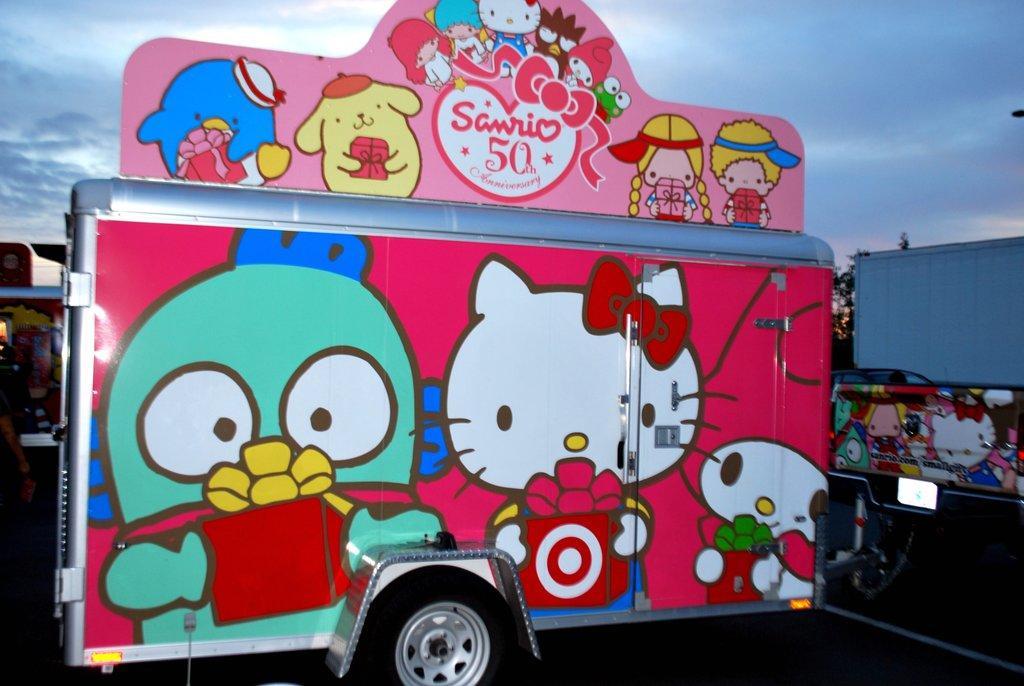In one or two sentences, can you explain what this image depicts? In the picture I can see a vehicle on the road and I can see the painting of dolls on the vehicle. I can see a container and a tree on the right side. I can see a car on the right side. There are clouds in the sky. 